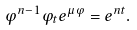<formula> <loc_0><loc_0><loc_500><loc_500>\varphi ^ { n - 1 } \varphi _ { t } e ^ { \mu \varphi } = e ^ { n t } .</formula> 